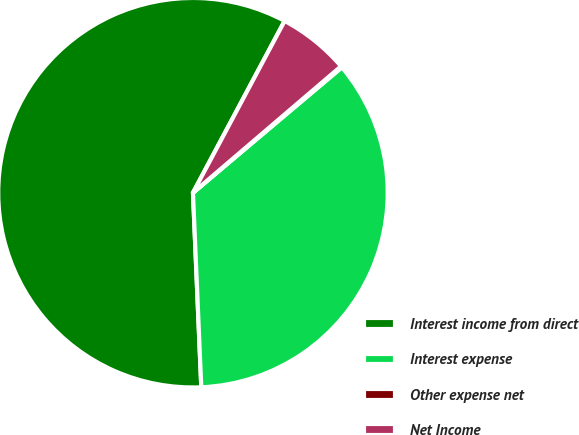Convert chart to OTSL. <chart><loc_0><loc_0><loc_500><loc_500><pie_chart><fcel>Interest income from direct<fcel>Interest expense<fcel>Other expense net<fcel>Net Income<nl><fcel>58.48%<fcel>35.46%<fcel>0.11%<fcel>5.95%<nl></chart> 